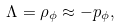Convert formula to latex. <formula><loc_0><loc_0><loc_500><loc_500>\Lambda = \rho _ { \phi } \approx - p _ { \phi } ,</formula> 